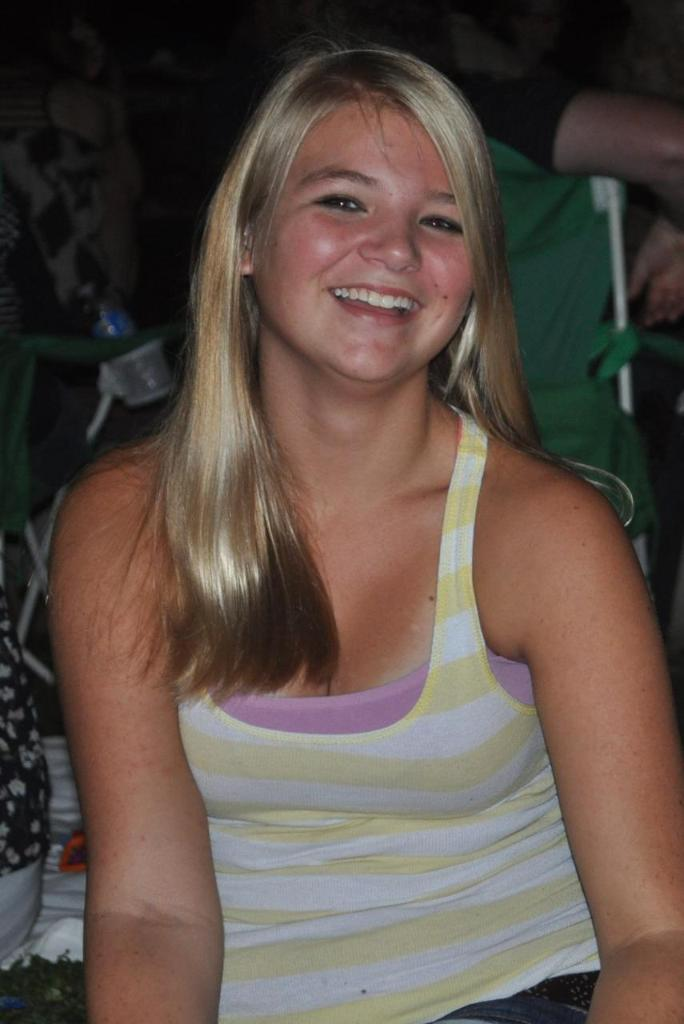Who is the main subject in the image? There is a woman in the image. What is the woman wearing? The woman is wearing a striped shirt. Can you describe the person in the background of the image? There is a person in the background of the image, and they are located towards the top right of the image. What type of religious symbol can be seen in the woman's hand in the image? There is no religious symbol visible in the woman's hand in the image. Can you describe the wave pattern in the background of the image? There is no wave pattern present in the image. 